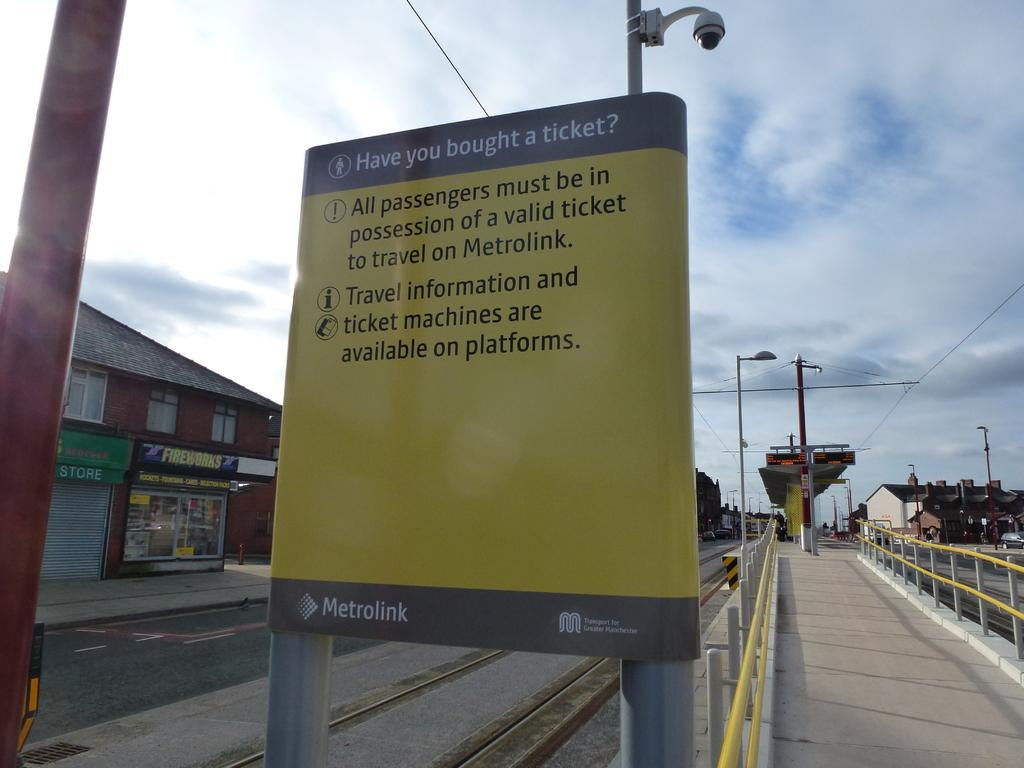<image>
Share a concise interpretation of the image provided. To travel on Metrolink, all passengers must be in possession of a valid ticket. 